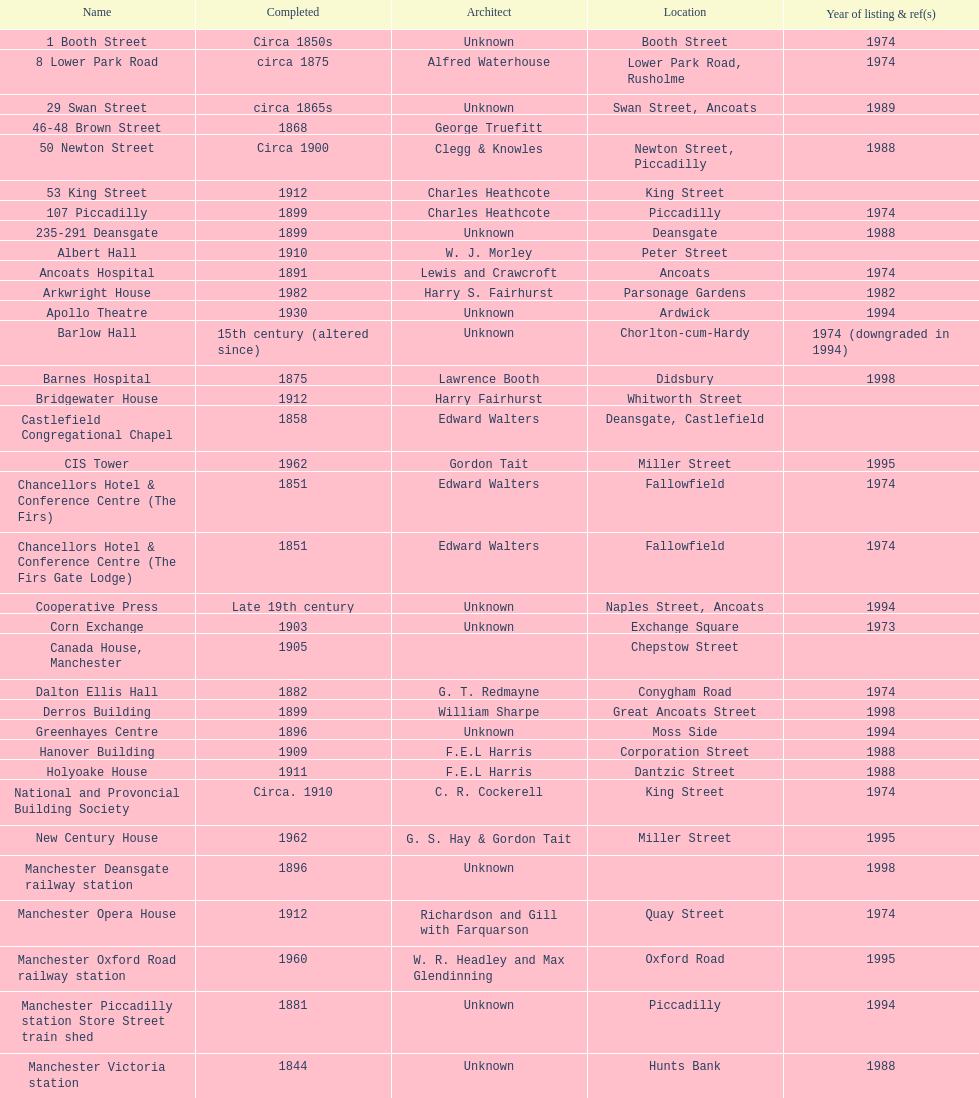What is the street of the only building listed in 1989? Swan Street. 